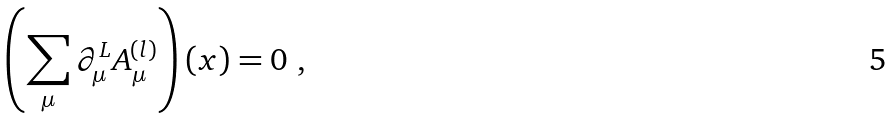<formula> <loc_0><loc_0><loc_500><loc_500>\left ( \sum _ { \mu } \partial _ { \mu } ^ { L } A ^ { ( l ) } _ { \mu } \right ) ( x ) = 0 \ ,</formula> 